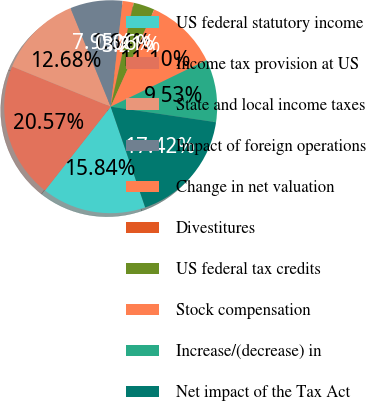<chart> <loc_0><loc_0><loc_500><loc_500><pie_chart><fcel>US federal statutory income<fcel>Income tax provision at US<fcel>State and local income taxes<fcel>Impact of foreign operations<fcel>Change in net valuation<fcel>Divestitures<fcel>US federal tax credits<fcel>Stock compensation<fcel>Increase/(decrease) in<fcel>Net impact of the Tax Act<nl><fcel>15.84%<fcel>20.57%<fcel>12.68%<fcel>7.95%<fcel>1.64%<fcel>0.06%<fcel>3.21%<fcel>11.1%<fcel>9.53%<fcel>17.42%<nl></chart> 